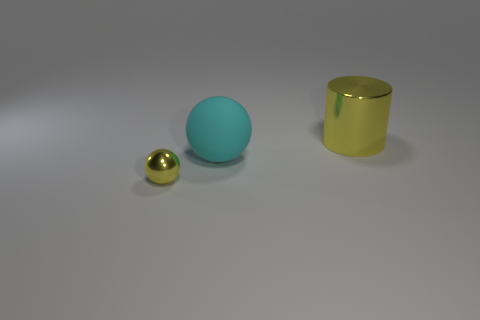Subtract all yellow spheres. How many spheres are left? 1 Subtract 2 spheres. How many spheres are left? 0 Subtract all blue cylinders. How many blue balls are left? 0 Add 3 big cyan objects. How many big cyan objects exist? 4 Add 1 metallic cylinders. How many objects exist? 4 Subtract 0 purple cylinders. How many objects are left? 3 Subtract all cylinders. How many objects are left? 2 Subtract all brown balls. Subtract all blue cylinders. How many balls are left? 2 Subtract all small yellow matte spheres. Subtract all big yellow cylinders. How many objects are left? 2 Add 2 cylinders. How many cylinders are left? 3 